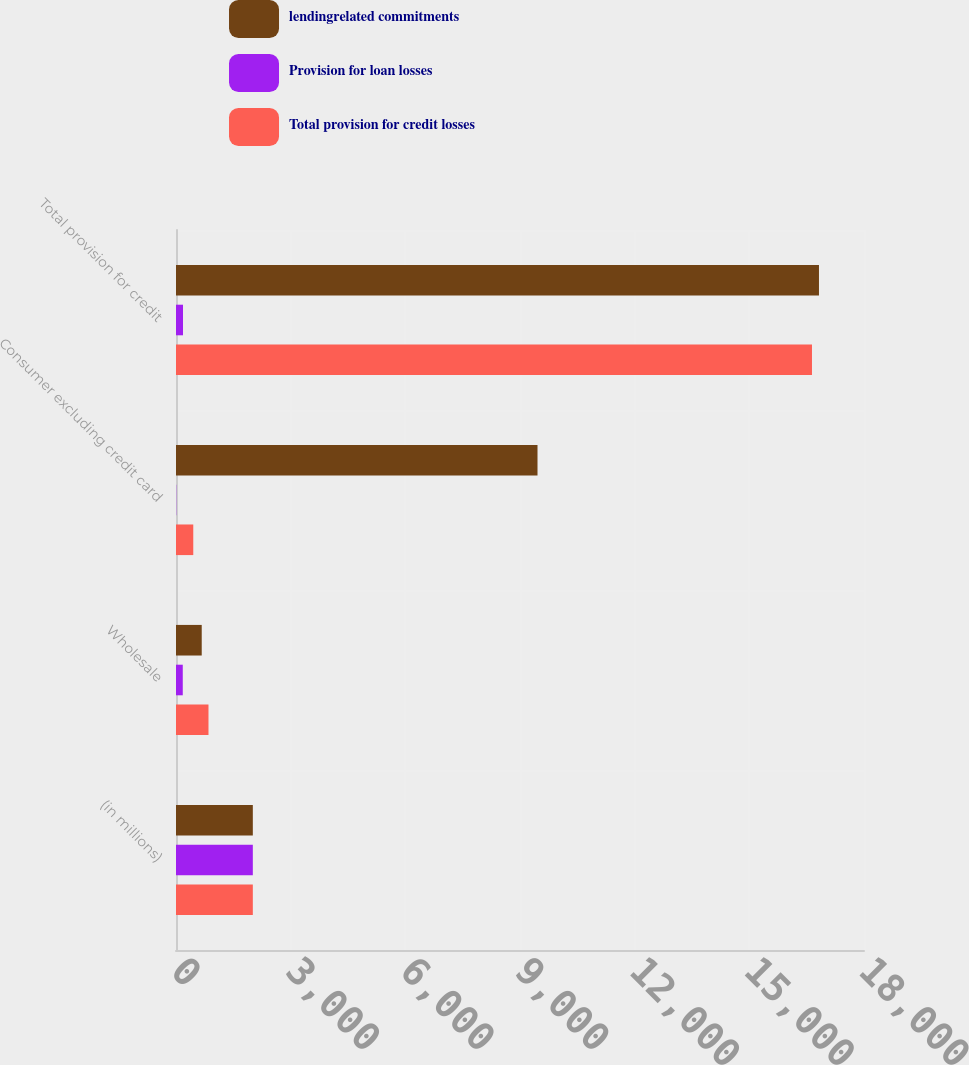Convert chart to OTSL. <chart><loc_0><loc_0><loc_500><loc_500><stacked_bar_chart><ecel><fcel>(in millions)<fcel>Wholesale<fcel>Consumer excluding credit card<fcel>Total provision for credit<nl><fcel>lendingrelated commitments<fcel>2010<fcel>673<fcel>9458<fcel>16822<nl><fcel>Provision for loan losses<fcel>2010<fcel>177<fcel>6<fcel>183<nl><fcel>Total provision for credit losses<fcel>2010<fcel>850<fcel>452<fcel>16639<nl></chart> 